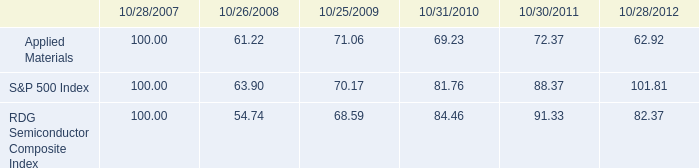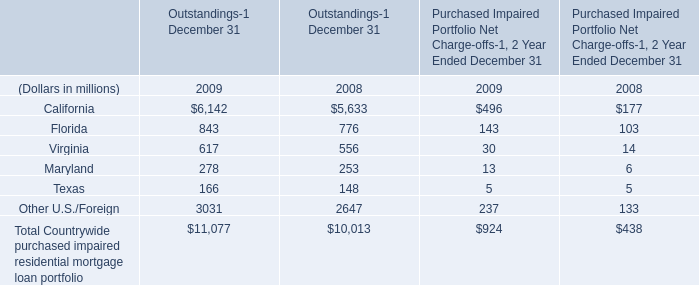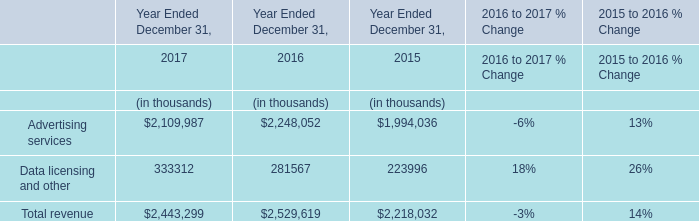how much did the quarterly dividend yield change from 2010 to 2012 for applied materials? 
Computations: ((0.09 / 62.92) - (0.07 / 69.23))
Answer: 0.00042. 